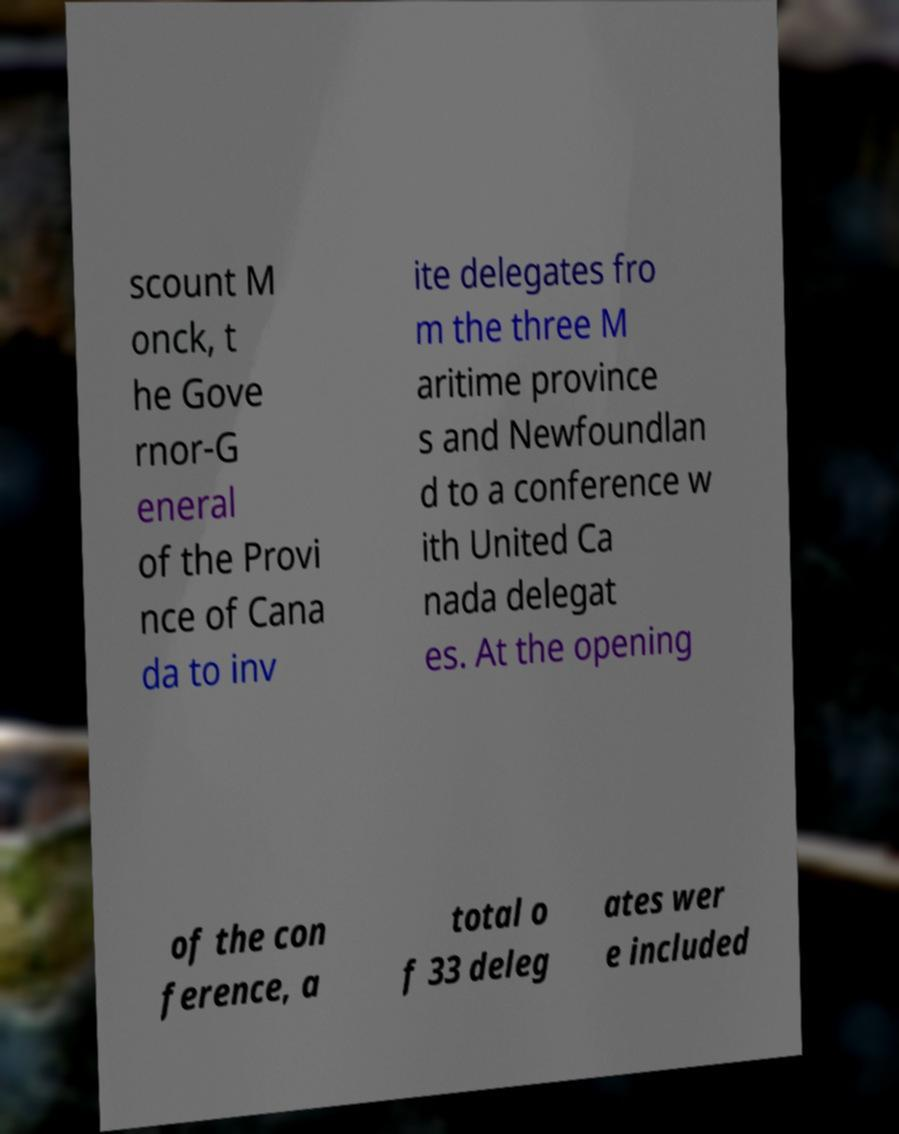There's text embedded in this image that I need extracted. Can you transcribe it verbatim? scount M onck, t he Gove rnor-G eneral of the Provi nce of Cana da to inv ite delegates fro m the three M aritime province s and Newfoundlan d to a conference w ith United Ca nada delegat es. At the opening of the con ference, a total o f 33 deleg ates wer e included 